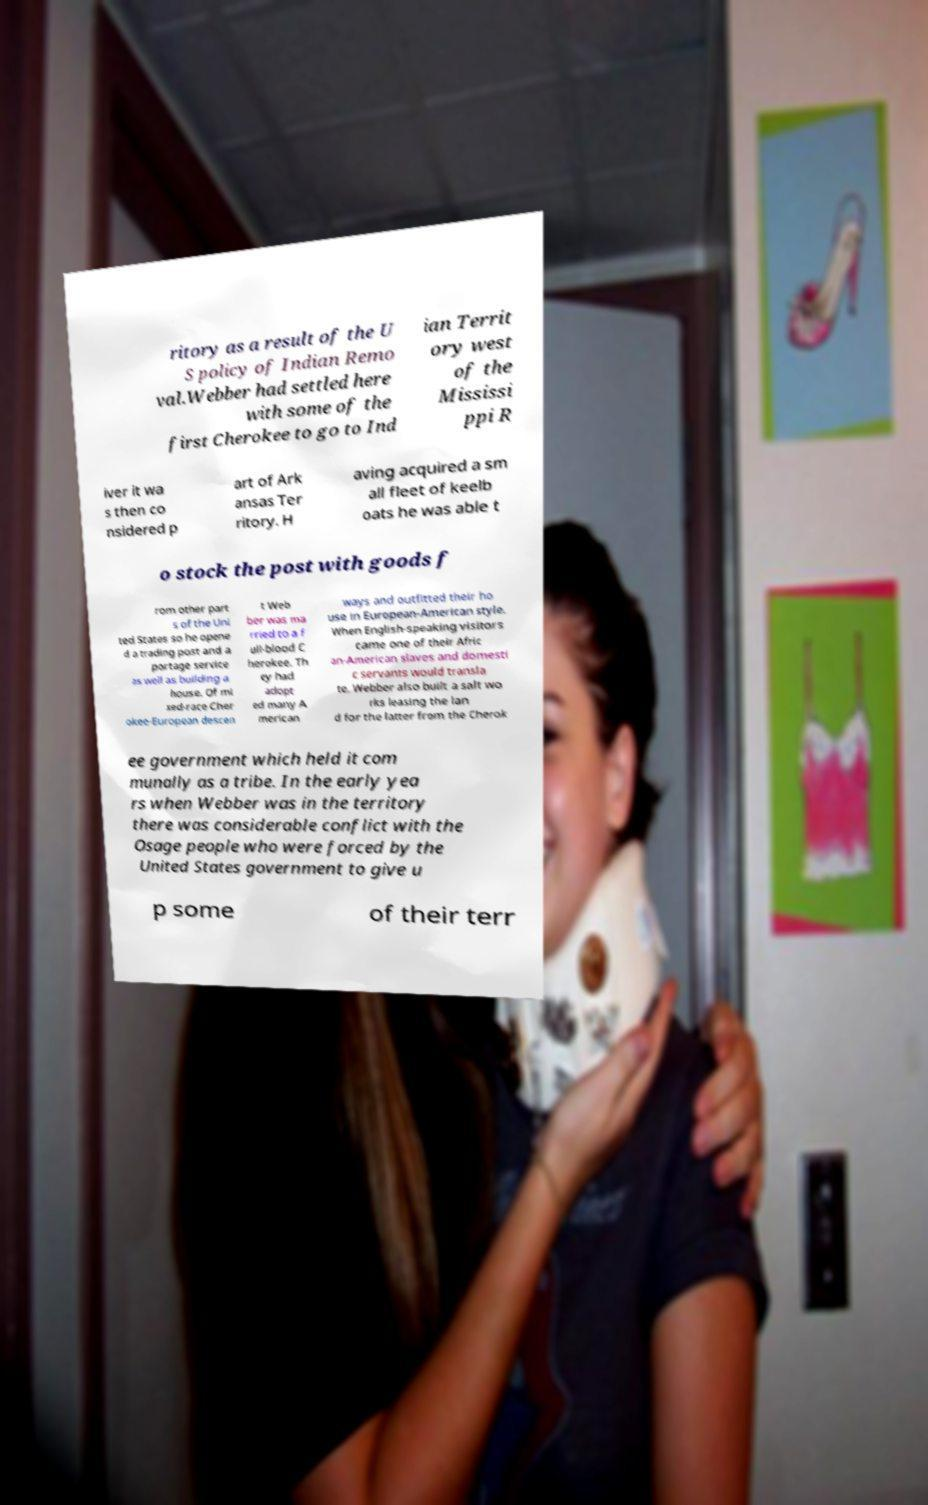Can you accurately transcribe the text from the provided image for me? ritory as a result of the U S policy of Indian Remo val.Webber had settled here with some of the first Cherokee to go to Ind ian Territ ory west of the Mississi ppi R iver it wa s then co nsidered p art of Ark ansas Ter ritory. H aving acquired a sm all fleet of keelb oats he was able t o stock the post with goods f rom other part s of the Uni ted States so he opene d a trading post and a portage service as well as building a house. Of mi xed-race Cher okee-European descen t Web ber was ma rried to a f ull-blood C herokee. Th ey had adopt ed many A merican ways and outfitted their ho use in European-American style. When English-speaking visitors came one of their Afric an-American slaves and domesti c servants would transla te. Webber also built a salt wo rks leasing the lan d for the latter from the Cherok ee government which held it com munally as a tribe. In the early yea rs when Webber was in the territory there was considerable conflict with the Osage people who were forced by the United States government to give u p some of their terr 